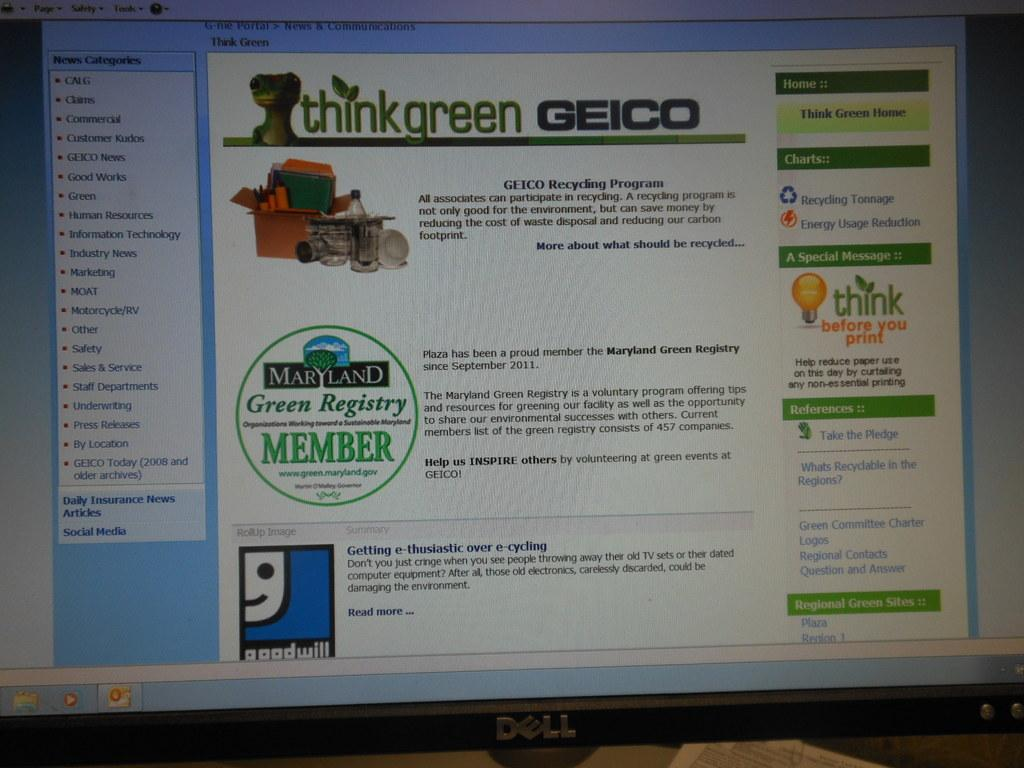<image>
Present a compact description of the photo's key features. a computer screen that is open to a page that says 'thinkgreen geico' 